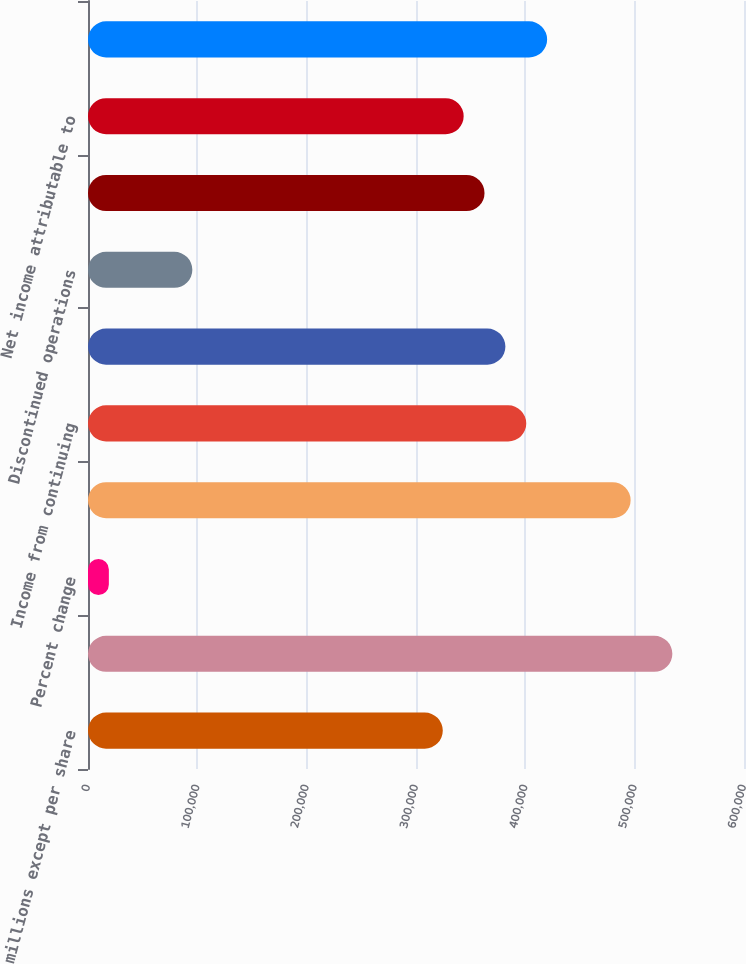Convert chart to OTSL. <chart><loc_0><loc_0><loc_500><loc_500><bar_chart><fcel>(In millions except per share<fcel>Revenues<fcel>Percent change<fcel>Gross profit<fcel>Income from continuing<fcel>Continuing operations<fcel>Discontinued operations<fcel>Net income<fcel>Net income attributable to<fcel>Working capital<nl><fcel>324502<fcel>534473<fcel>19089.4<fcel>496297<fcel>400855<fcel>381767<fcel>95442.5<fcel>362679<fcel>343590<fcel>419943<nl></chart> 